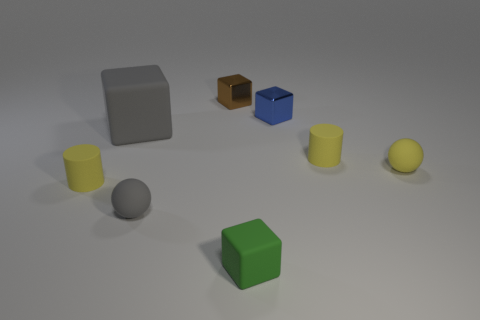Are there fewer yellow spheres to the left of the large cube than gray things?
Keep it short and to the point. Yes. What shape is the small green thing that is the same material as the gray block?
Make the answer very short. Cube. There is a tiny yellow object left of the big matte block; does it have the same shape as the yellow thing behind the yellow sphere?
Your response must be concise. Yes. Are there fewer tiny yellow rubber objects that are behind the small brown cube than cubes that are left of the small blue object?
Provide a succinct answer. Yes. What is the shape of the other rubber thing that is the same color as the large object?
Offer a very short reply. Sphere. How many blue cubes are the same size as the yellow rubber sphere?
Provide a succinct answer. 1. Does the yellow thing on the left side of the tiny brown thing have the same material as the blue cube?
Keep it short and to the point. No. There is a gray block that is made of the same material as the green thing; what size is it?
Provide a short and direct response. Large. Is there a tiny matte sphere of the same color as the big matte cube?
Offer a terse response. Yes. Is the color of the rubber cylinder that is on the right side of the tiny brown cube the same as the tiny cylinder on the left side of the small green object?
Your response must be concise. Yes. 